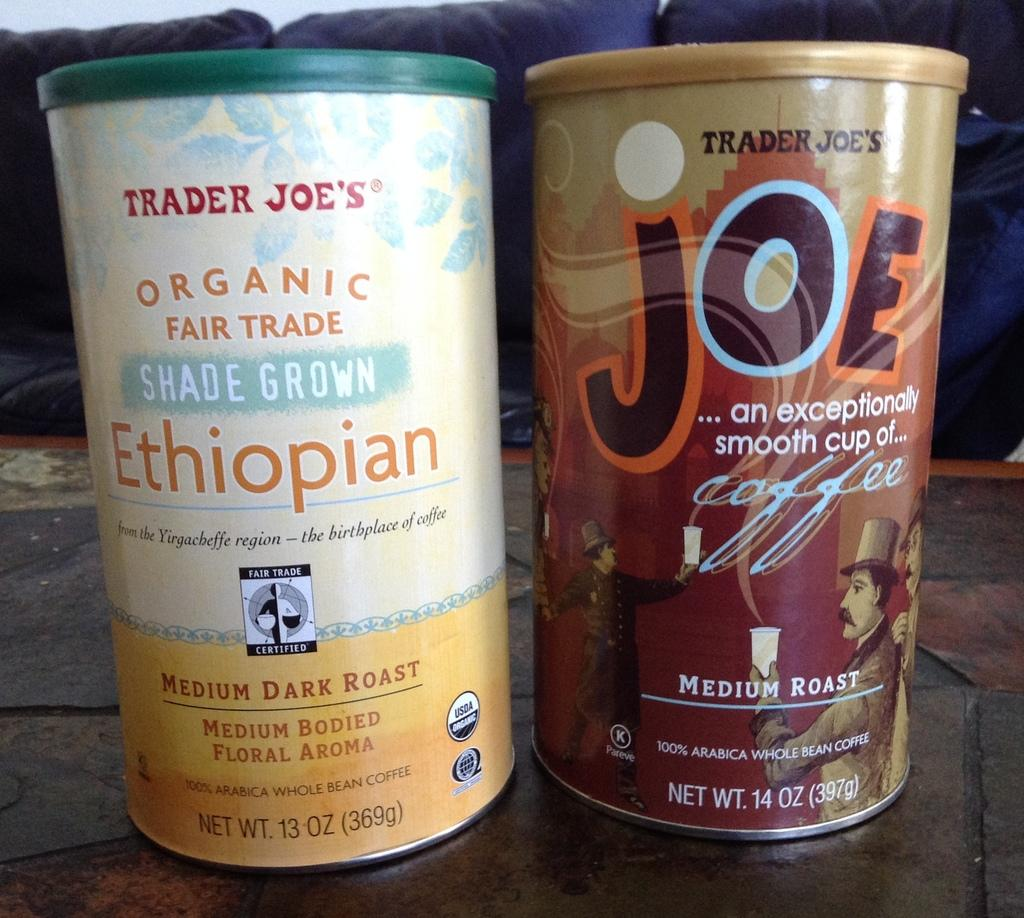How many objects are present in the image? There are two objects in the image. Where are the objects located? Both objects are placed on a plank. What distinguishes the two objects from each other? Each object has a different coffee brand name. What type of ring is visible on the finger of the person holding the coffee cup in the image? There is no person holding a coffee cup or wearing a ring in the image. 